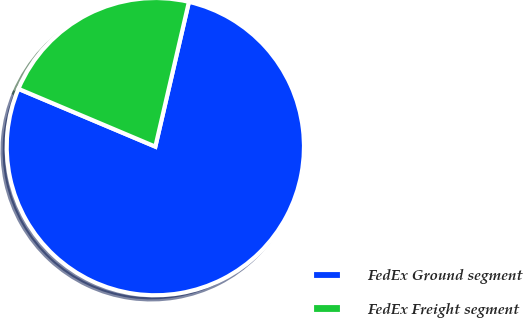Convert chart. <chart><loc_0><loc_0><loc_500><loc_500><pie_chart><fcel>FedEx Ground segment<fcel>FedEx Freight segment<nl><fcel>77.73%<fcel>22.27%<nl></chart> 